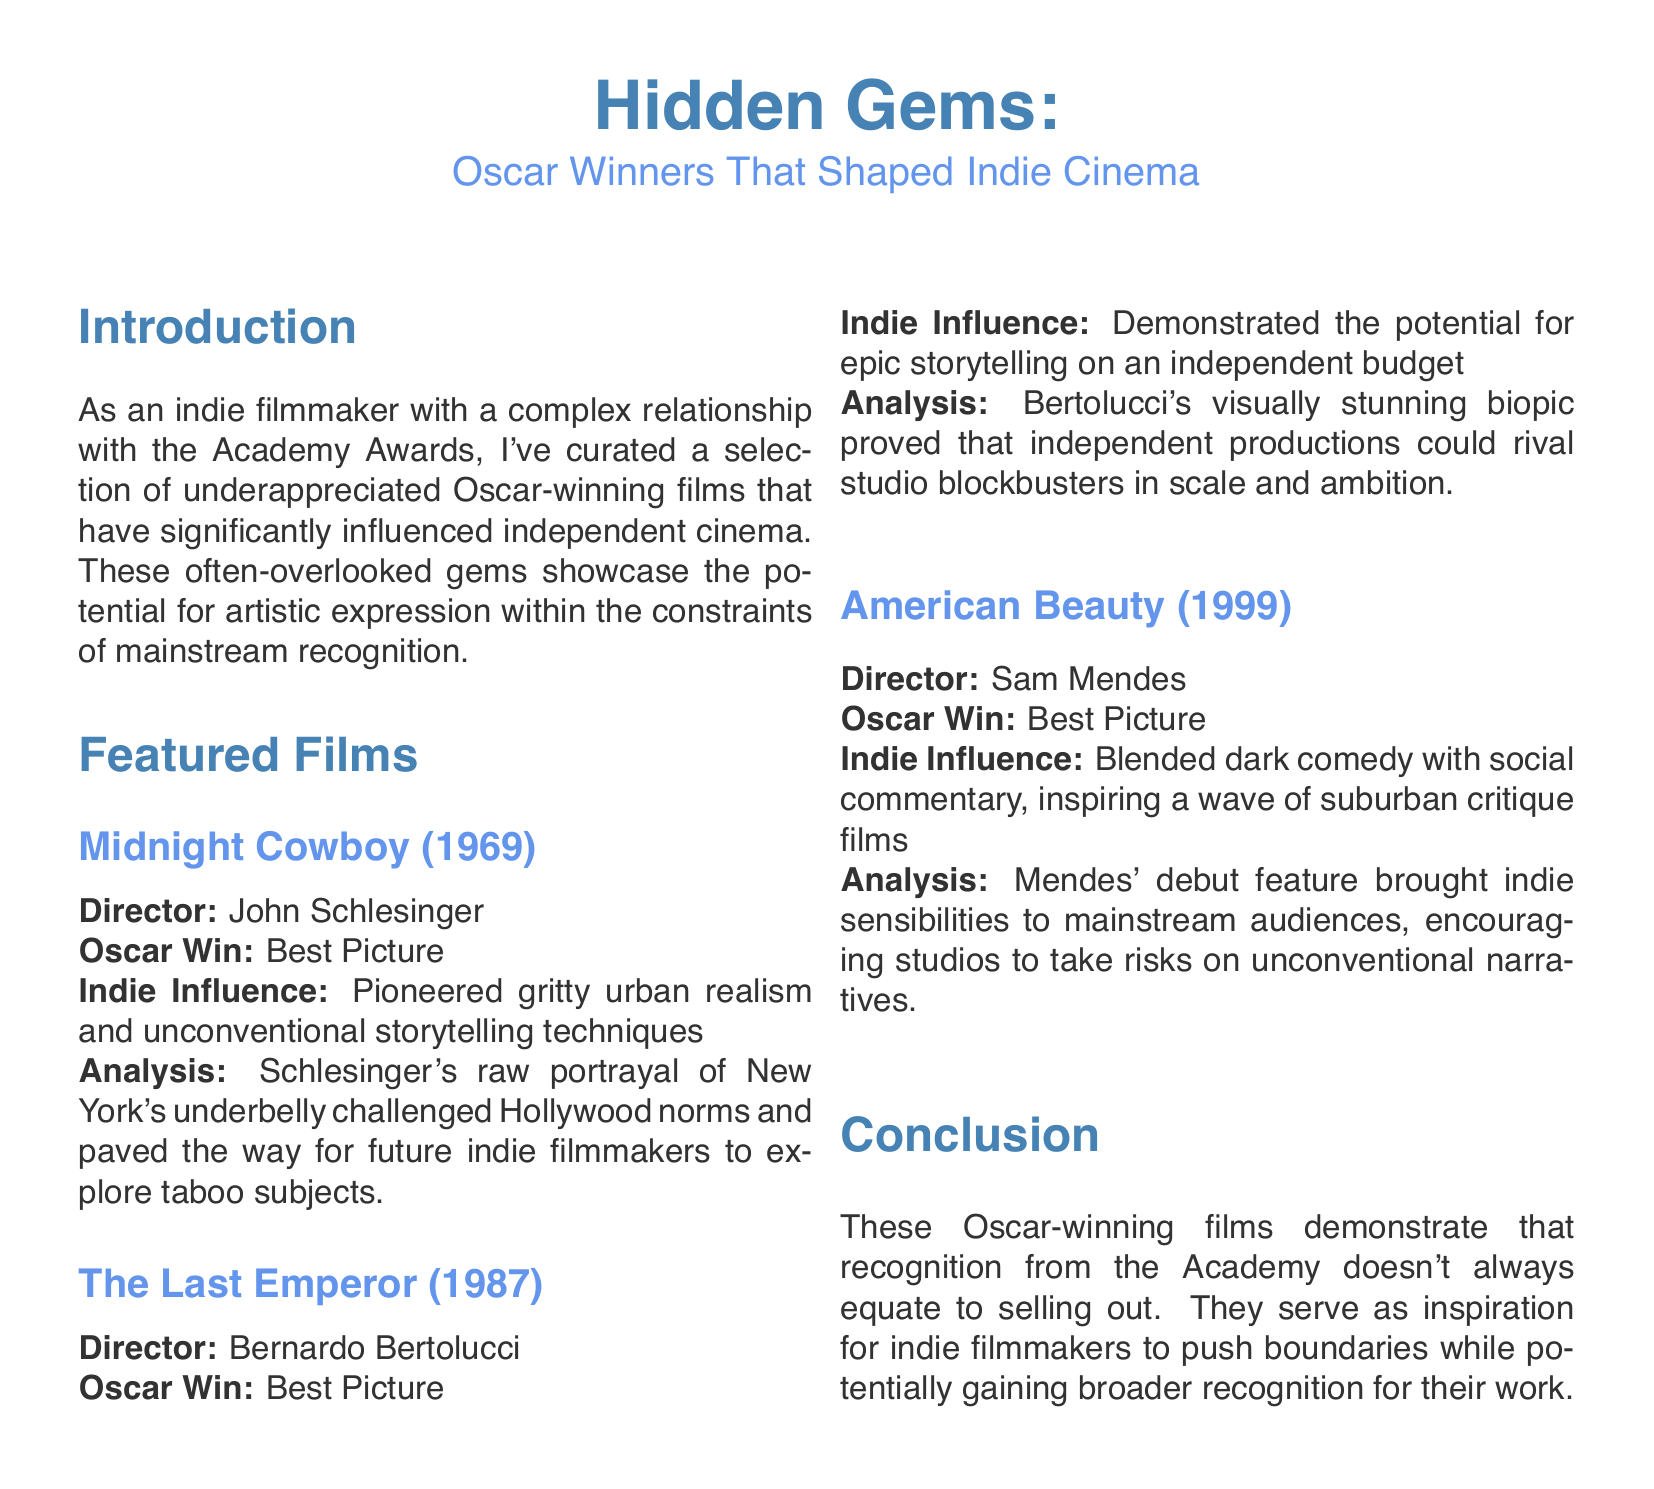what is the title of the document? The title is mentioned in the header at the beginning of the document.
Answer: Hidden Gems: Oscar Winners That Shaped Indie Cinema who directed Midnight Cowboy? The director of Midnight Cowboy is specified in the document.
Answer: John Schlesinger what year did The Last Emperor win the Oscar? The year of the Oscar win for The Last Emperor is stated in the document.
Answer: 1987 which film is mentioned as a precursor to suburban critique films? This film is noted for its influence on a genre exploring suburban themes.
Answer: American Beauty what is the Oscar category won by American Beauty? This is explicitly stated in the section for that film.
Answer: Best Picture how many films are featured in the document? The number of films is found by tallying the listed films in the Featured Films section.
Answer: three what artistic expression aspect did Midnight Cowboy pioneer? This describes the thematic contribution of the film as mentioned in its analysis.
Answer: gritty urban realism what does the analysis of The Last Emperor highlight about independent productions? The analysis specifically points out a distinctive quality of independent productions.
Answer: rival studio blockbusters in scale and ambition what is the main theme explored in the conclusion of the document? The conclusion wraps up the discussion and identifies a primary theme.
Answer: inspiration for indie filmmakers 